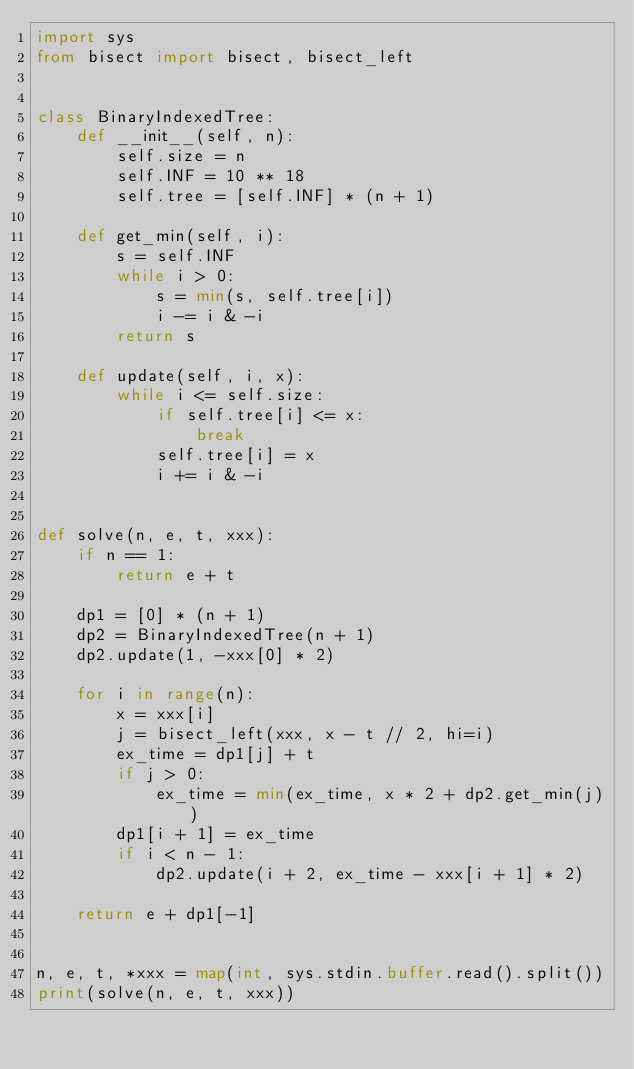<code> <loc_0><loc_0><loc_500><loc_500><_Python_>import sys
from bisect import bisect, bisect_left


class BinaryIndexedTree:
    def __init__(self, n):
        self.size = n
        self.INF = 10 ** 18
        self.tree = [self.INF] * (n + 1)

    def get_min(self, i):
        s = self.INF
        while i > 0:
            s = min(s, self.tree[i])
            i -= i & -i
        return s

    def update(self, i, x):
        while i <= self.size:
            if self.tree[i] <= x:
                break
            self.tree[i] = x
            i += i & -i


def solve(n, e, t, xxx):
    if n == 1:
        return e + t

    dp1 = [0] * (n + 1)
    dp2 = BinaryIndexedTree(n + 1)
    dp2.update(1, -xxx[0] * 2)

    for i in range(n):
        x = xxx[i]
        j = bisect_left(xxx, x - t // 2, hi=i)
        ex_time = dp1[j] + t
        if j > 0:
            ex_time = min(ex_time, x * 2 + dp2.get_min(j))
        dp1[i + 1] = ex_time
        if i < n - 1:
            dp2.update(i + 2, ex_time - xxx[i + 1] * 2)

    return e + dp1[-1]


n, e, t, *xxx = map(int, sys.stdin.buffer.read().split())
print(solve(n, e, t, xxx))
</code> 